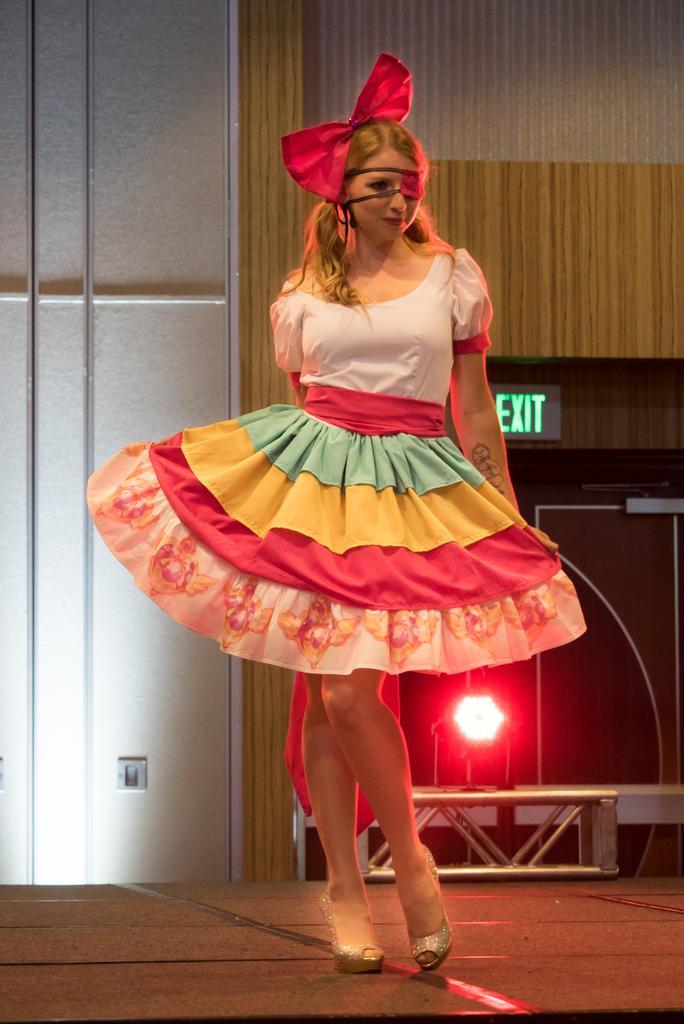Could you give a brief overview of what you see in this image? In the image there is a girl, she is wearing a frock and behind her there is a speaker, a red colour light and in the background there is a wall. 